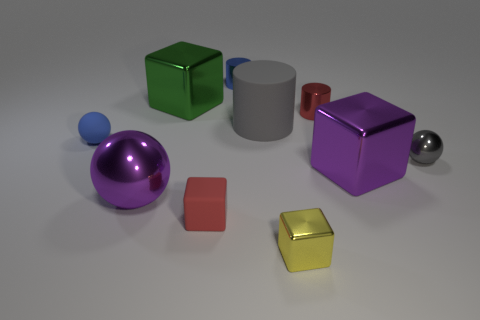How many large purple objects have the same shape as the green metal object?
Your answer should be very brief. 1. Do the metal sphere to the right of the matte block and the large matte cylinder have the same color?
Your answer should be very brief. Yes. There is a blue metal object that is the same shape as the red metal object; what is its size?
Provide a short and direct response. Small. There is a metal block that is behind the tiny blue rubber thing; what size is it?
Your answer should be very brief. Large. Does the matte cylinder have the same color as the small shiny sphere?
Your answer should be very brief. Yes. Is there any other thing that is the same shape as the large green object?
Your answer should be very brief. Yes. There is a object that is the same color as the small metallic sphere; what is its material?
Your answer should be very brief. Rubber. Is the number of blue cylinders that are left of the large purple metallic sphere the same as the number of tiny red cylinders?
Offer a very short reply. No. There is a tiny rubber ball; are there any big shiny balls behind it?
Ensure brevity in your answer.  No. There is a tiny yellow object; does it have the same shape as the small matte object that is on the right side of the big ball?
Keep it short and to the point. Yes. 